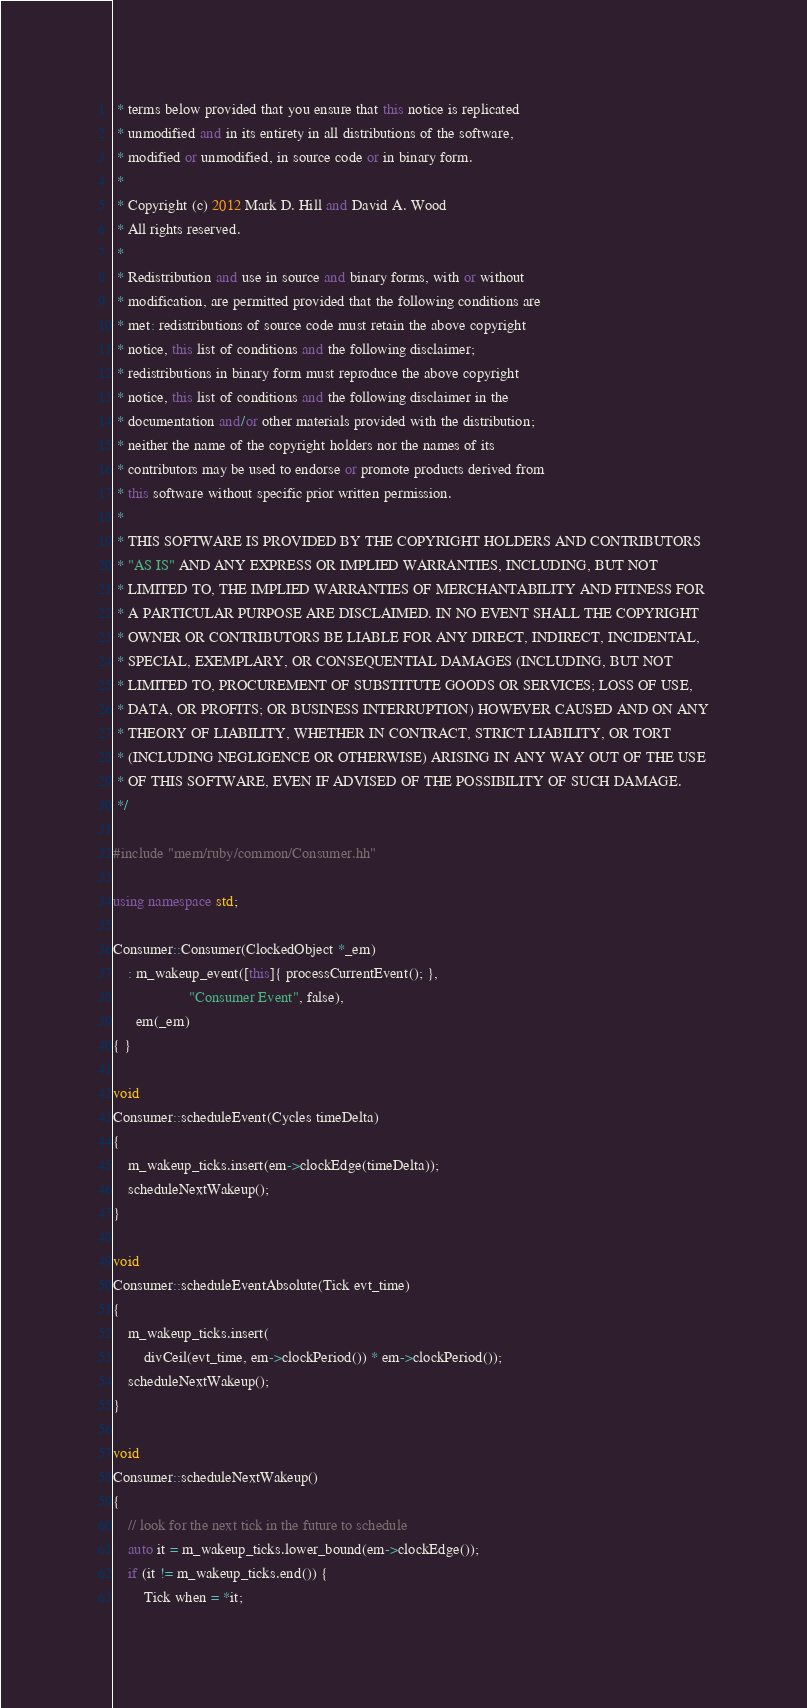<code> <loc_0><loc_0><loc_500><loc_500><_C++_> * terms below provided that you ensure that this notice is replicated
 * unmodified and in its entirety in all distributions of the software,
 * modified or unmodified, in source code or in binary form.
 *
 * Copyright (c) 2012 Mark D. Hill and David A. Wood
 * All rights reserved.
 *
 * Redistribution and use in source and binary forms, with or without
 * modification, are permitted provided that the following conditions are
 * met: redistributions of source code must retain the above copyright
 * notice, this list of conditions and the following disclaimer;
 * redistributions in binary form must reproduce the above copyright
 * notice, this list of conditions and the following disclaimer in the
 * documentation and/or other materials provided with the distribution;
 * neither the name of the copyright holders nor the names of its
 * contributors may be used to endorse or promote products derived from
 * this software without specific prior written permission.
 *
 * THIS SOFTWARE IS PROVIDED BY THE COPYRIGHT HOLDERS AND CONTRIBUTORS
 * "AS IS" AND ANY EXPRESS OR IMPLIED WARRANTIES, INCLUDING, BUT NOT
 * LIMITED TO, THE IMPLIED WARRANTIES OF MERCHANTABILITY AND FITNESS FOR
 * A PARTICULAR PURPOSE ARE DISCLAIMED. IN NO EVENT SHALL THE COPYRIGHT
 * OWNER OR CONTRIBUTORS BE LIABLE FOR ANY DIRECT, INDIRECT, INCIDENTAL,
 * SPECIAL, EXEMPLARY, OR CONSEQUENTIAL DAMAGES (INCLUDING, BUT NOT
 * LIMITED TO, PROCUREMENT OF SUBSTITUTE GOODS OR SERVICES; LOSS OF USE,
 * DATA, OR PROFITS; OR BUSINESS INTERRUPTION) HOWEVER CAUSED AND ON ANY
 * THEORY OF LIABILITY, WHETHER IN CONTRACT, STRICT LIABILITY, OR TORT
 * (INCLUDING NEGLIGENCE OR OTHERWISE) ARISING IN ANY WAY OUT OF THE USE
 * OF THIS SOFTWARE, EVEN IF ADVISED OF THE POSSIBILITY OF SUCH DAMAGE.
 */

#include "mem/ruby/common/Consumer.hh"

using namespace std;

Consumer::Consumer(ClockedObject *_em)
    : m_wakeup_event([this]{ processCurrentEvent(); },
                    "Consumer Event", false),
      em(_em)
{ }

void
Consumer::scheduleEvent(Cycles timeDelta)
{
    m_wakeup_ticks.insert(em->clockEdge(timeDelta));
    scheduleNextWakeup();
}

void
Consumer::scheduleEventAbsolute(Tick evt_time)
{
    m_wakeup_ticks.insert(
        divCeil(evt_time, em->clockPeriod()) * em->clockPeriod());
    scheduleNextWakeup();
}

void
Consumer::scheduleNextWakeup()
{
    // look for the next tick in the future to schedule
    auto it = m_wakeup_ticks.lower_bound(em->clockEdge());
    if (it != m_wakeup_ticks.end()) {
        Tick when = *it;</code> 